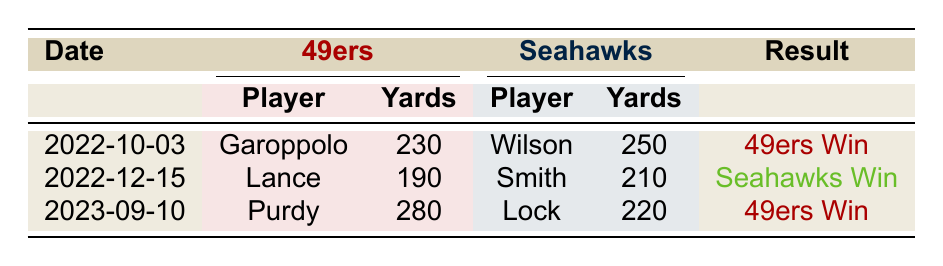What was the outcome of the matchup on October 3, 2022? The table indicates that the result of the game held on October 3, 2022, was a victory for the 49ers.
Answer: 49ers Win Which player had the highest passing yards in the matchups? On reviewing the passing yards column, Brock Purdy had the highest passing yards of 280 in the matchup on September 10, 2023.
Answer: Brock Purdy Did any 49ers player throw for 300 passing yards? The table does not show any player from the 49ers reaching 300 passing yards in any of the matchups listed.
Answer: No What is the average passing yards of the Seahawks players across the matchups? The total passing yards for the Seahawks players are 250 (Wilson) + 210 (Smith) + 220 (Lock) = 680. There are three matchups, so the average is 680/3 = 226.67.
Answer: 226.67 Which player from the 49ers had the lowest completion percentage? By checking the completion percentage column, Trey Lance had the lowest completion percentage of 70.0 among 49ers players.
Answer: Trey Lance How many touchdowns did Russell Wilson throw in the match on October 3, 2022? In the table, it shows that Russell Wilson threw for 1 touchdown in the game on October 3, 2022.
Answer: 1 Was there a matchup where both quarterbacks had at least 2 touchdowns? The table shows no matchups where both quarterbacks had at least 2 touchdowns simultaneously; Trey Lance (1) and Garoppolo (2) in one game does not fulfill this while Geno Smith (2) and Lock (1) in another also does not.
Answer: No Which team won the matchup on December 15, 2022? From the table, it is clear that the Seahawks won the matchup held on December 15, 2022.
Answer: Seahawks Win What is the difference in passing yards between the Seahawks and 49ers in the matchup on September 10, 2023? The passing yards for the Seahawks (220) and 49ers (280) had a difference of 280 - 220 = 60 there.
Answer: 60 